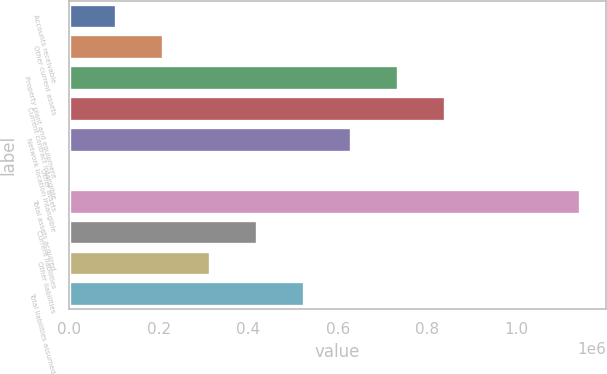<chart> <loc_0><loc_0><loc_500><loc_500><bar_chart><fcel>Accounts receivable<fcel>Other current assets<fcel>Property plant and equipment<fcel>Current contract intangible<fcel>Network location intangible<fcel>Other assets<fcel>Total assets acquired<fcel>Current liabilities<fcel>Other liabilities<fcel>Total liabilities assumed<nl><fcel>105714<fcel>210703<fcel>735644<fcel>840632<fcel>630656<fcel>726<fcel>1.14214e+06<fcel>420679<fcel>315691<fcel>525668<nl></chart> 